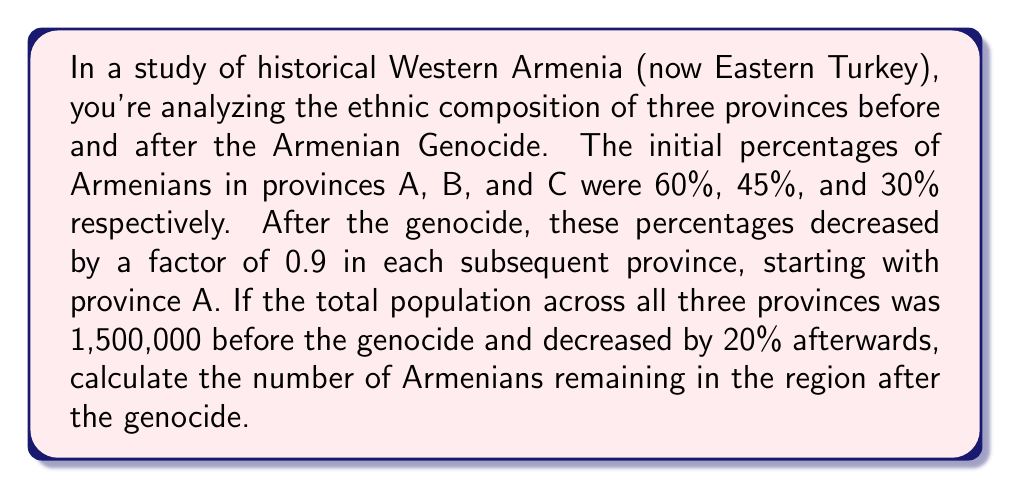Solve this math problem. Let's approach this step-by-step:

1) First, let's calculate the new percentages of Armenians in each province after the genocide:

   Province A: $60\% \times 0.9 = 54\%$
   Province B: $54\% \times 0.9 = 48.6\%$
   Province C: $48.6\% \times 0.9 = 43.74\%$

2) Now, let's calculate the new total population:
   $1,500,000 \times (1 - 0.2) = 1,200,000$

3) To find the number of Armenians, we need to know what fraction of the total population each province represents. Let's assume they're equal for simplicity:
   Each province: $1,200,000 \div 3 = 400,000$

4) Now we can calculate the number of Armenians in each province:

   Province A: $400,000 \times 0.54 = 216,000$
   Province B: $400,000 \times 0.486 = 194,400$
   Province C: $400,000 \times 0.4374 = 174,960$

5) The total number of Armenians remaining is the sum of these:

   $216,000 + 194,400 + 174,960 = 585,360$
Answer: 585,360 Armenians 